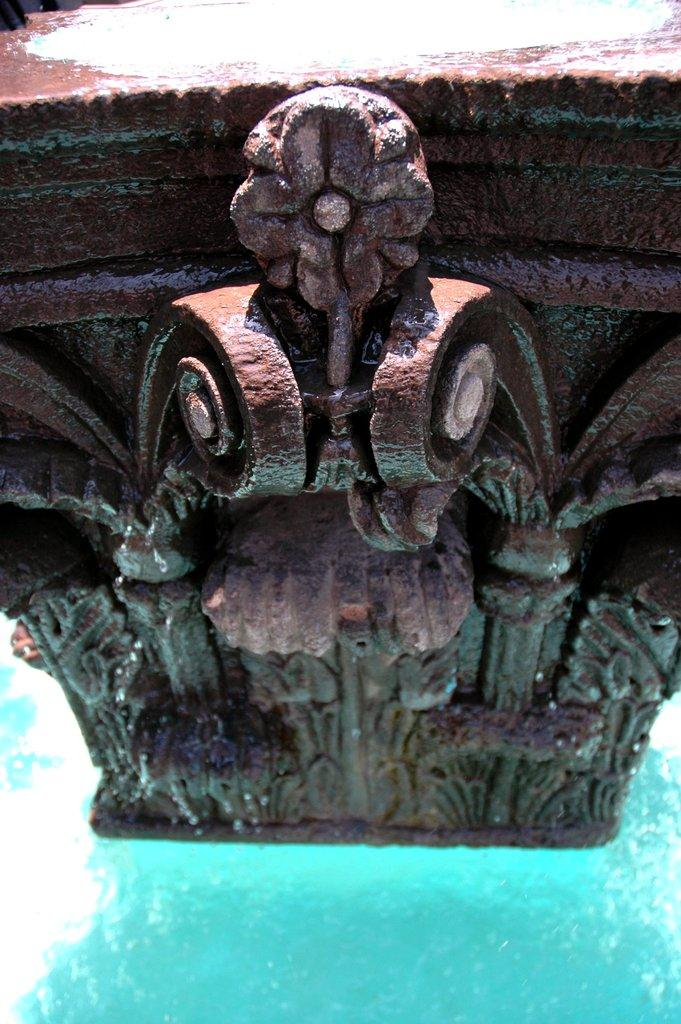What is the main object in the image? There is a carved stone in the image. What is present at the bottom of the image? There is water at the bottom of the image. What type of yoke is being used to control the fire in the image? There is no yoke or fire present in the image; it features a carved stone and water. 